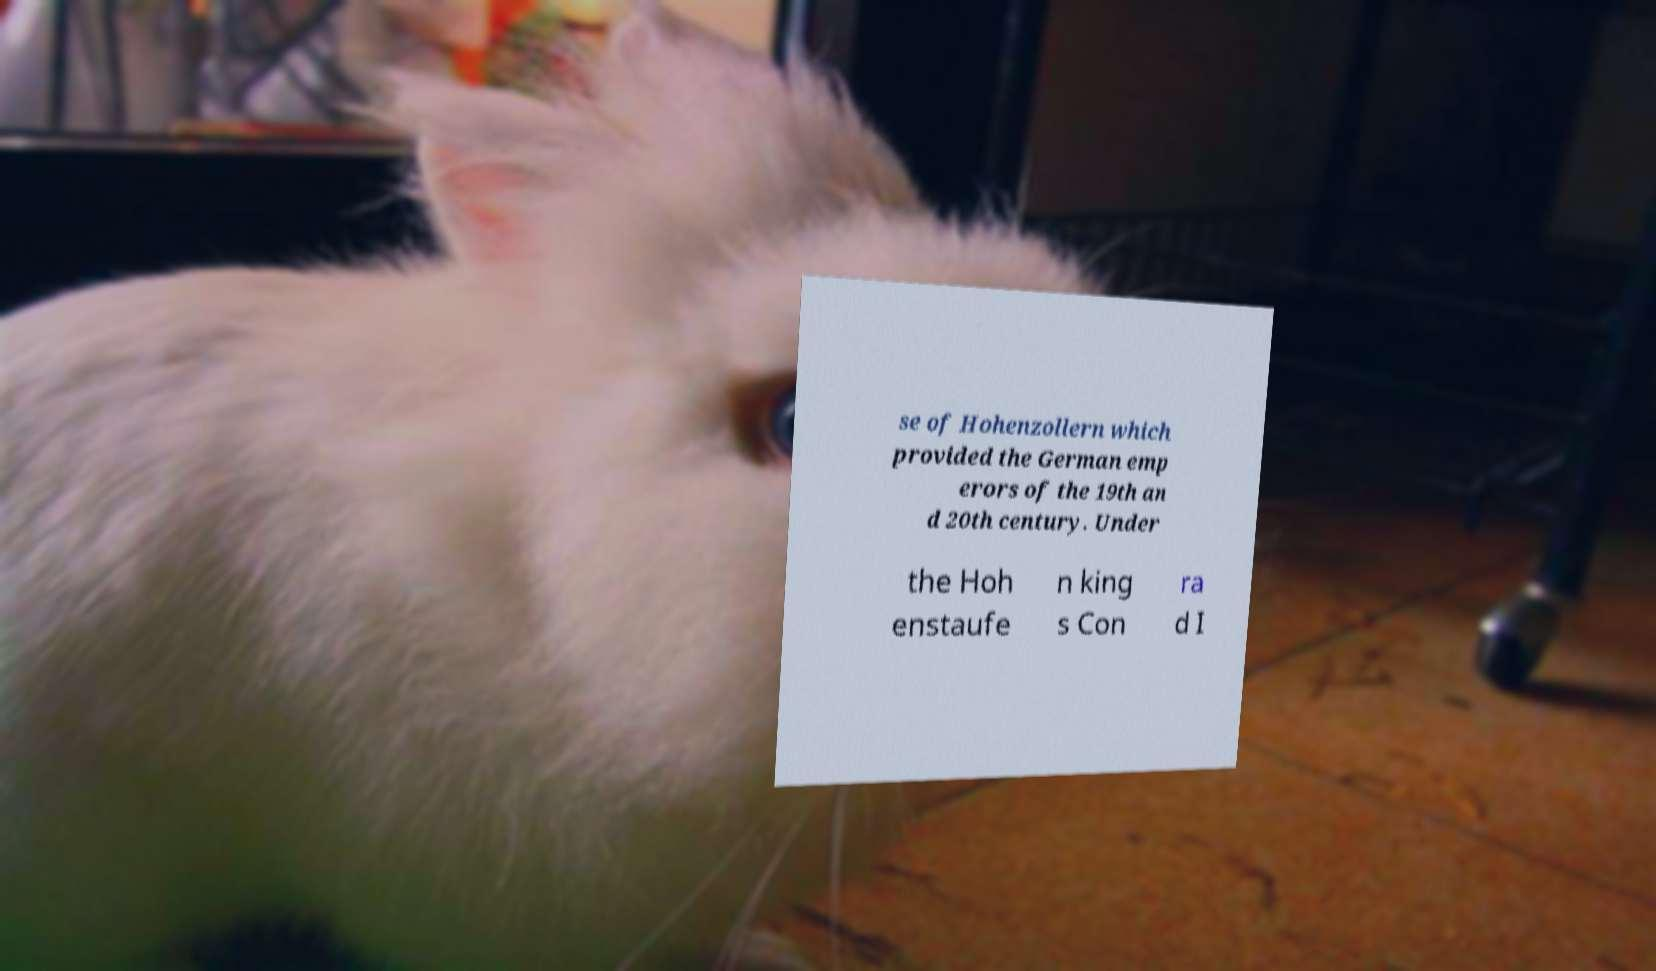There's text embedded in this image that I need extracted. Can you transcribe it verbatim? se of Hohenzollern which provided the German emp erors of the 19th an d 20th century. Under the Hoh enstaufe n king s Con ra d I 